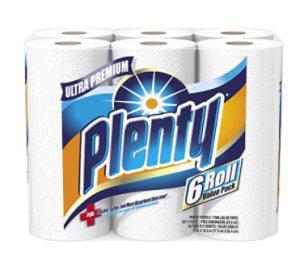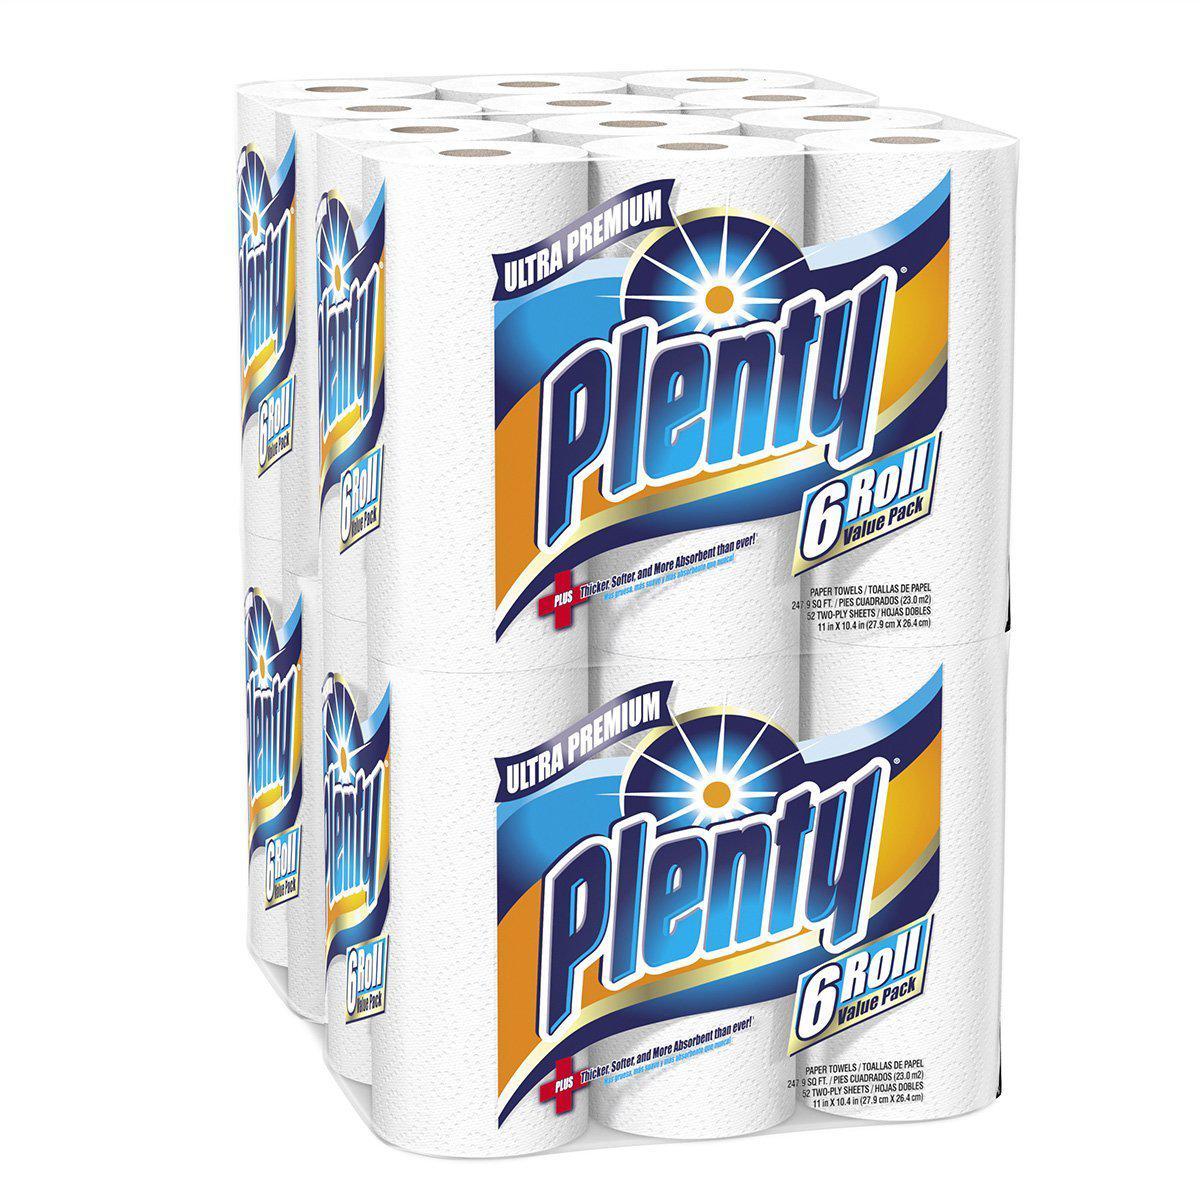The first image is the image on the left, the second image is the image on the right. For the images shown, is this caption "Each image shows an individually-wrapped single roll of paper towels, and left and right packages have the same sunburst logo on front." true? Answer yes or no. No. The first image is the image on the left, the second image is the image on the right. Given the left and right images, does the statement "Two individually wrapped rolls of paper towels are both standing upright and have similar brand labels, but are shown with different background colors." hold true? Answer yes or no. No. 